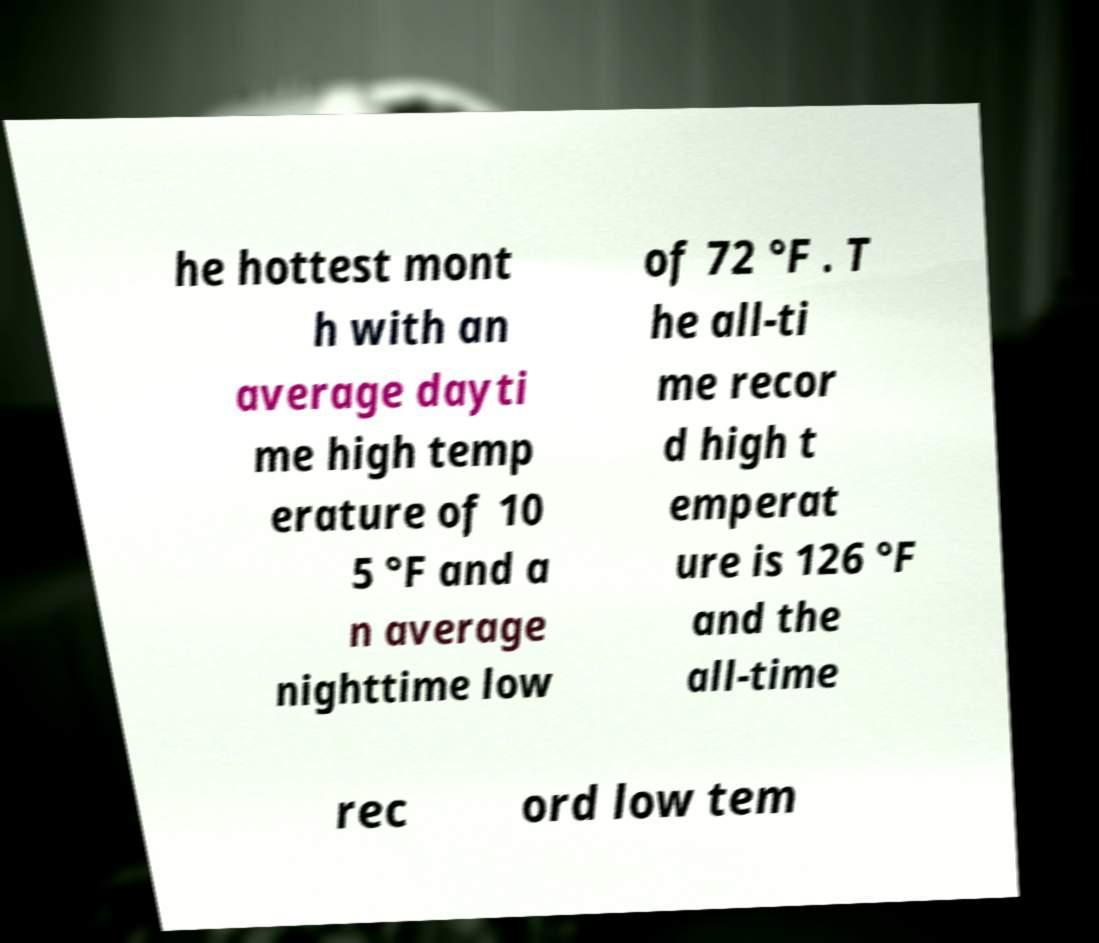Please identify and transcribe the text found in this image. he hottest mont h with an average dayti me high temp erature of 10 5 °F and a n average nighttime low of 72 °F . T he all-ti me recor d high t emperat ure is 126 °F and the all-time rec ord low tem 